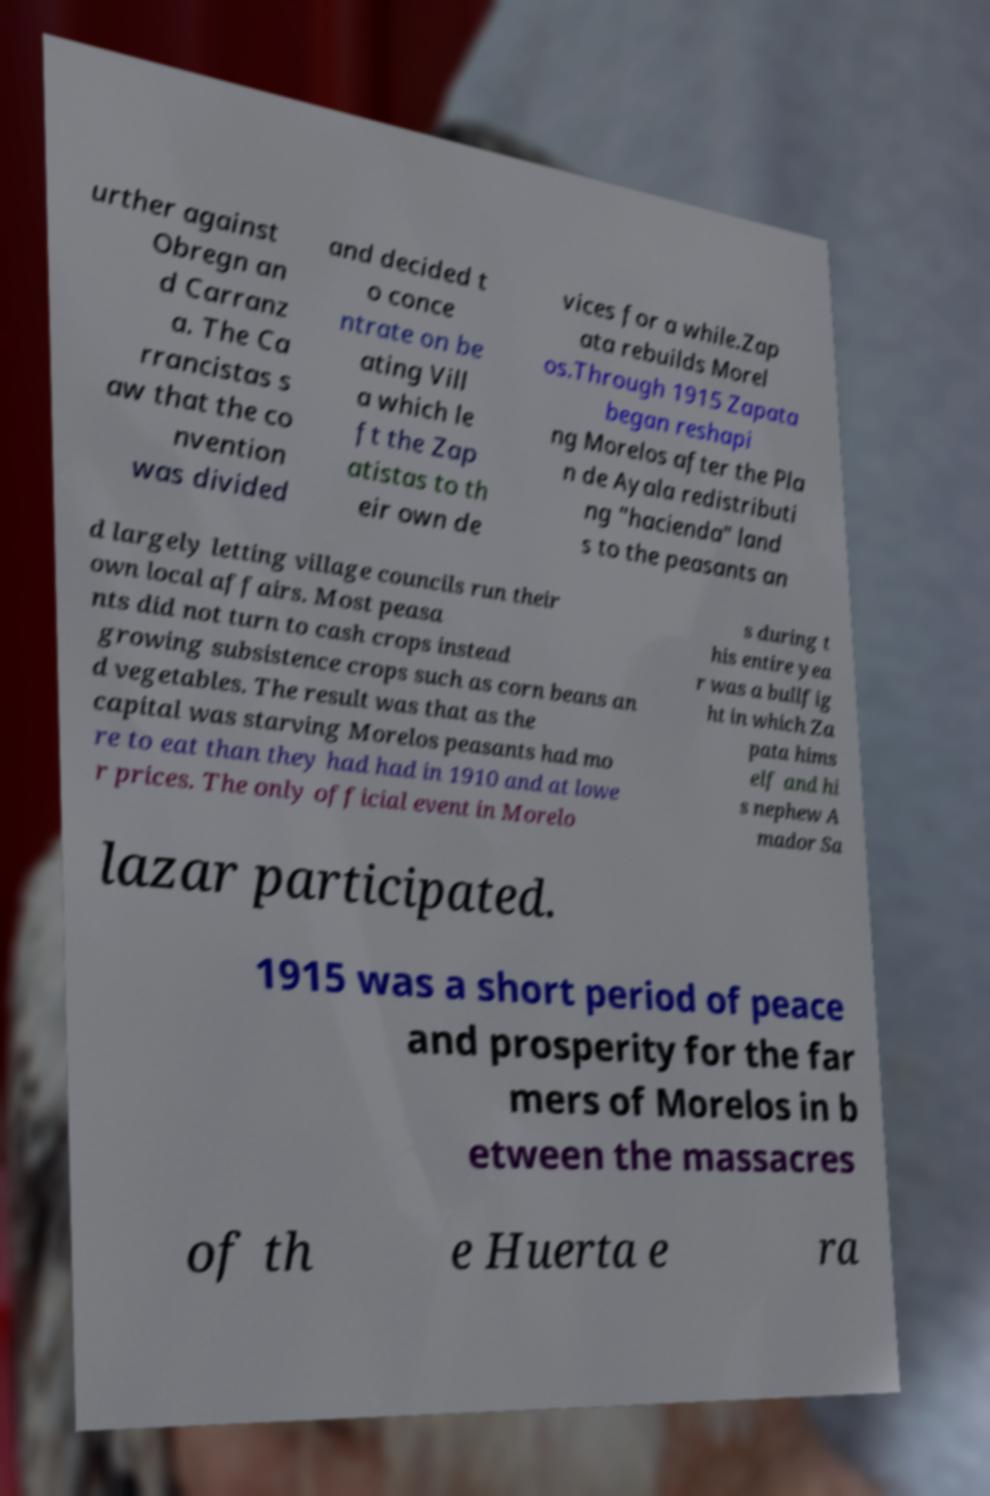Could you extract and type out the text from this image? urther against Obregn an d Carranz a. The Ca rrancistas s aw that the co nvention was divided and decided t o conce ntrate on be ating Vill a which le ft the Zap atistas to th eir own de vices for a while.Zap ata rebuilds Morel os.Through 1915 Zapata began reshapi ng Morelos after the Pla n de Ayala redistributi ng "hacienda" land s to the peasants an d largely letting village councils run their own local affairs. Most peasa nts did not turn to cash crops instead growing subsistence crops such as corn beans an d vegetables. The result was that as the capital was starving Morelos peasants had mo re to eat than they had had in 1910 and at lowe r prices. The only official event in Morelo s during t his entire yea r was a bullfig ht in which Za pata hims elf and hi s nephew A mador Sa lazar participated. 1915 was a short period of peace and prosperity for the far mers of Morelos in b etween the massacres of th e Huerta e ra 